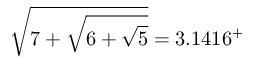<formula> <loc_0><loc_0><loc_500><loc_500>{ \sqrt { 7 + { \sqrt { 6 + { \sqrt { 5 } } } } } } = 3 . 1 4 1 6 ^ { + }</formula> 